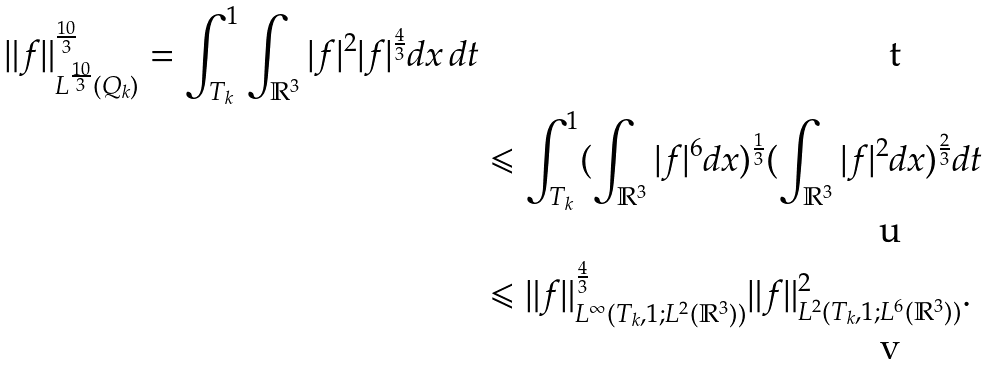<formula> <loc_0><loc_0><loc_500><loc_500>\| f \| _ { L ^ { \frac { 1 0 } { 3 } } ( Q _ { k } ) } ^ { \frac { 1 0 } { 3 } } = \int _ { T _ { k } } ^ { 1 } \int _ { \mathbb { R } ^ { 3 } } | f | ^ { 2 } | f | ^ { \frac { 4 } { 3 } } d x \, d t \\ & \leqslant \int _ { T _ { k } } ^ { 1 } ( \int _ { \mathbb { R } ^ { 3 } } | f | ^ { 6 } d x ) ^ { \frac { 1 } { 3 } } ( \int _ { \mathbb { R } ^ { 3 } } | f | ^ { 2 } d x ) ^ { \frac { 2 } { 3 } } d t \\ & \leqslant \| f \| _ { L ^ { \infty } ( T _ { k } , 1 ; L ^ { 2 } ( \mathbb { R } ^ { 3 } ) ) } ^ { \frac { 4 } { 3 } } \| f \| _ { L ^ { 2 } ( T _ { k } , 1 ; L ^ { 6 } ( \mathbb { R } ^ { 3 } ) ) } ^ { 2 } .</formula> 